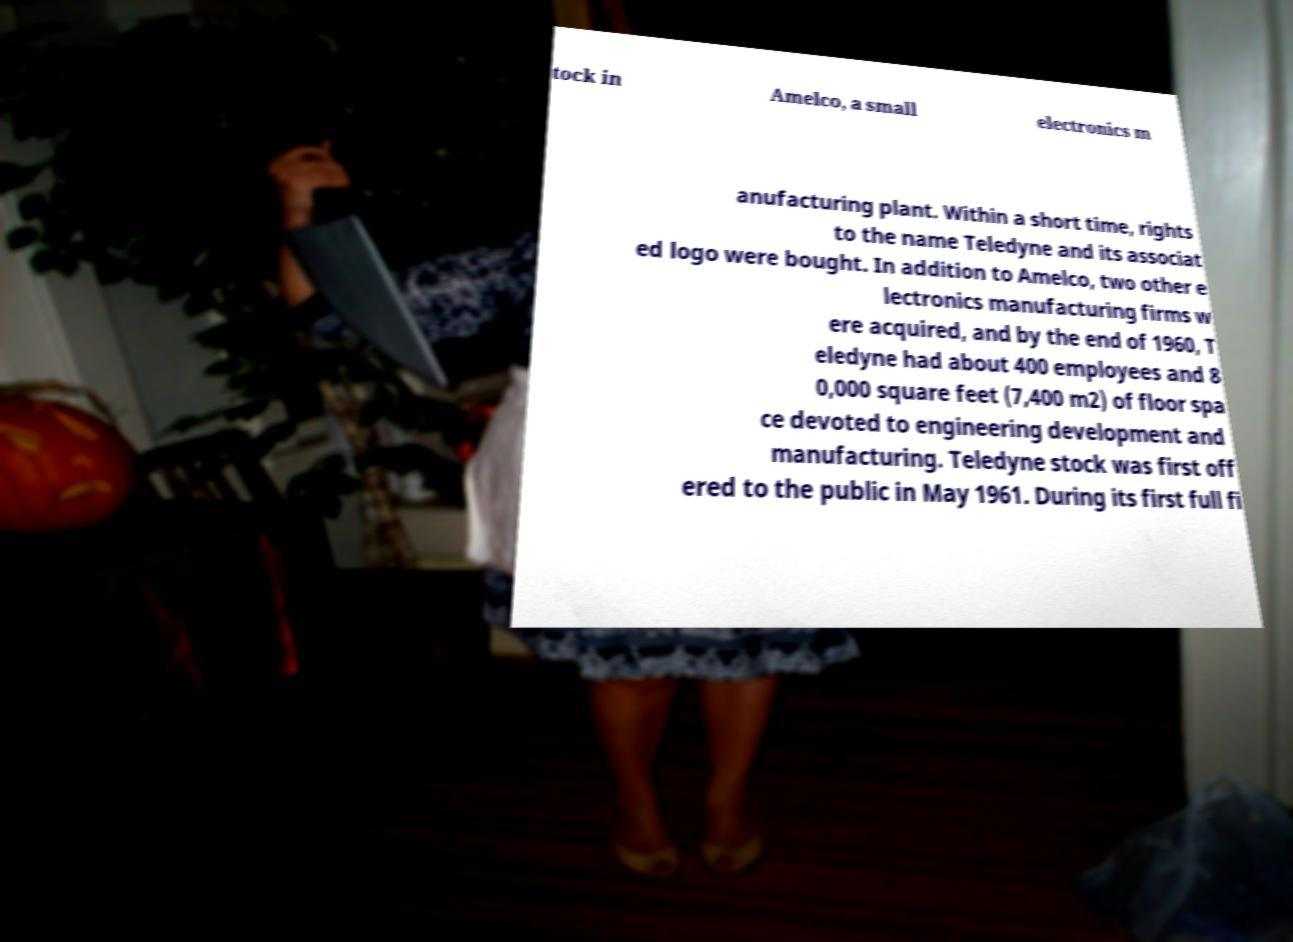For documentation purposes, I need the text within this image transcribed. Could you provide that? tock in Amelco, a small electronics m anufacturing plant. Within a short time, rights to the name Teledyne and its associat ed logo were bought. In addition to Amelco, two other e lectronics manufacturing firms w ere acquired, and by the end of 1960, T eledyne had about 400 employees and 8 0,000 square feet (7,400 m2) of floor spa ce devoted to engineering development and manufacturing. Teledyne stock was first off ered to the public in May 1961. During its first full fi 